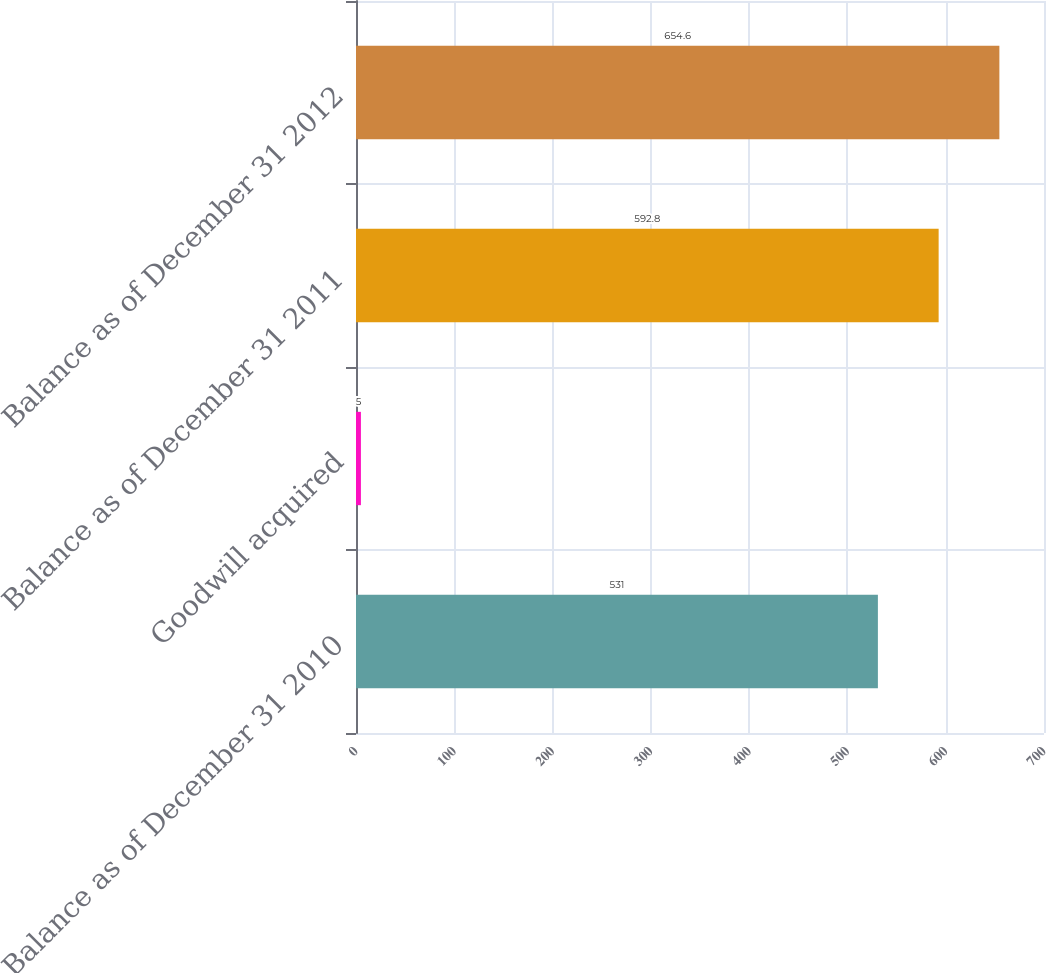<chart> <loc_0><loc_0><loc_500><loc_500><bar_chart><fcel>Balance as of December 31 2010<fcel>Goodwill acquired<fcel>Balance as of December 31 2011<fcel>Balance as of December 31 2012<nl><fcel>531<fcel>5<fcel>592.8<fcel>654.6<nl></chart> 